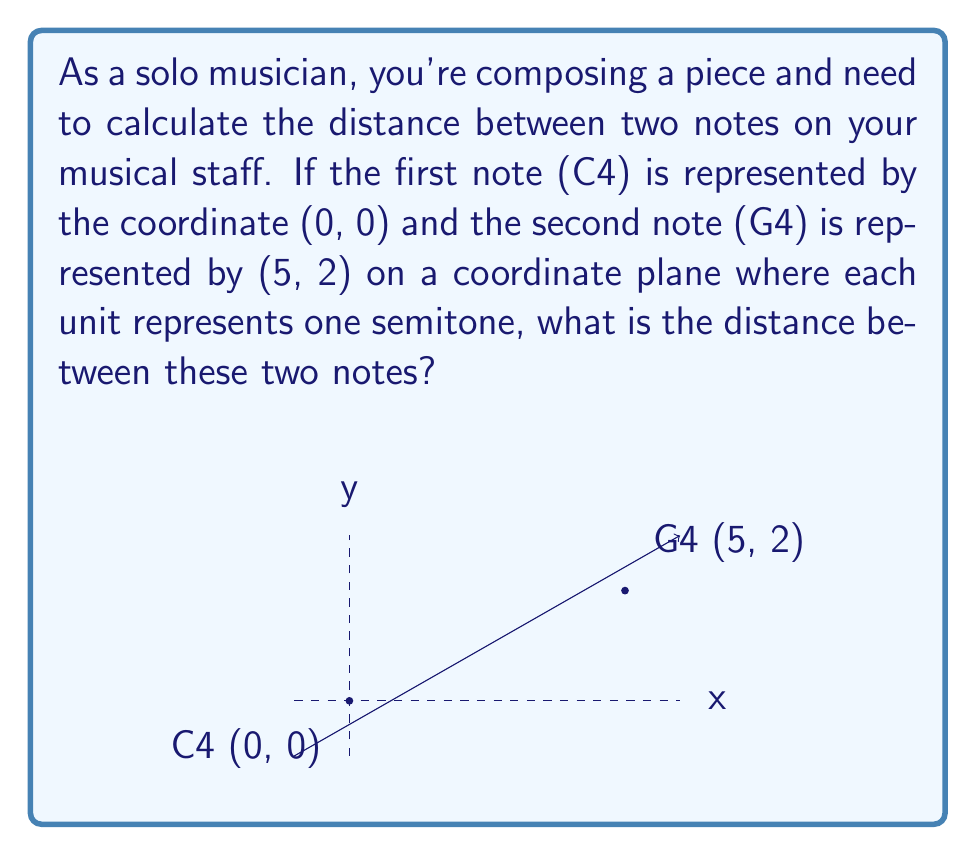Provide a solution to this math problem. To solve this problem, we can use the distance formula derived from the Pythagorean theorem:

$$d = \sqrt{(x_2 - x_1)^2 + (y_2 - y_1)^2}$$

Where $(x_1, y_1)$ represents the coordinates of the first point and $(x_2, y_2)$ represents the coordinates of the second point.

Given:
- C4 is at (0, 0)
- G4 is at (5, 2)

Let's substitute these values into the formula:

$$\begin{align}
d &= \sqrt{(5 - 0)^2 + (2 - 0)^2} \\
&= \sqrt{5^2 + 2^2} \\
&= \sqrt{25 + 4} \\
&= \sqrt{29}
\end{align}$$

The distance between the two notes is $\sqrt{29}$ units.

In musical terms, this distance represents the interval between C4 and G4, which is a perfect fifth. The horizontal distance (5) represents the number of letter names between C and G, while the vertical distance (2) represents the octave adjustment.
Answer: $\sqrt{29}$ units 